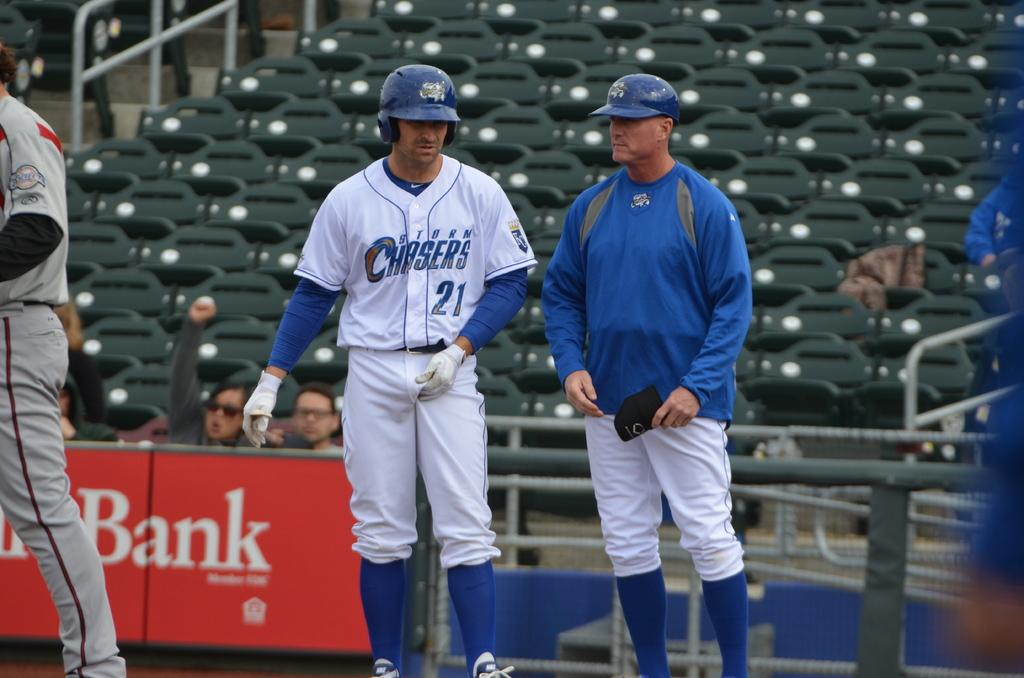<image>
Create a compact narrative representing the image presented. Two baseball players  for the Storm Chasers stand together on the field. 